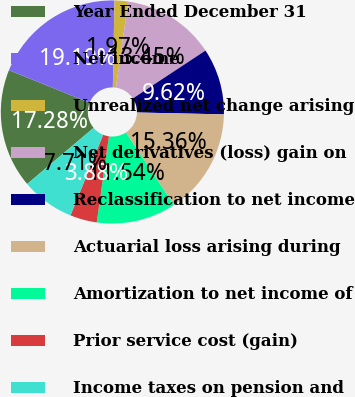<chart> <loc_0><loc_0><loc_500><loc_500><pie_chart><fcel>Year Ended December 31<fcel>Net income<fcel>Unrealized net change arising<fcel>Net derivatives (loss) gain on<fcel>Reclassification to net income<fcel>Actuarial loss arising during<fcel>Amortization to net income of<fcel>Prior service cost (gain)<fcel>Income taxes on pension and<nl><fcel>17.28%<fcel>19.19%<fcel>1.97%<fcel>13.45%<fcel>9.62%<fcel>15.36%<fcel>11.54%<fcel>3.88%<fcel>7.71%<nl></chart> 